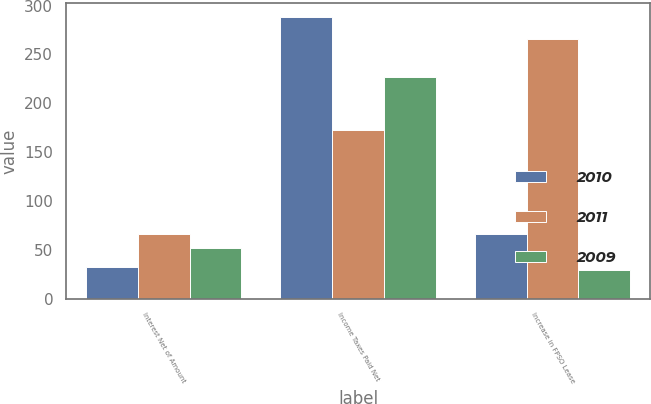Convert chart. <chart><loc_0><loc_0><loc_500><loc_500><stacked_bar_chart><ecel><fcel>Interest Net of Amount<fcel>Income Taxes Paid Net<fcel>Increase in FPSO Lease<nl><fcel>2010<fcel>32<fcel>288<fcel>66<nl><fcel>2011<fcel>66<fcel>173<fcel>266<nl><fcel>2009<fcel>52<fcel>227<fcel>29<nl></chart> 